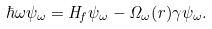<formula> <loc_0><loc_0><loc_500><loc_500>\hbar { \omega } \psi _ { \omega } = H _ { f } \psi _ { \omega } - \Omega _ { \omega } ( r ) \gamma \psi _ { \omega } .</formula> 